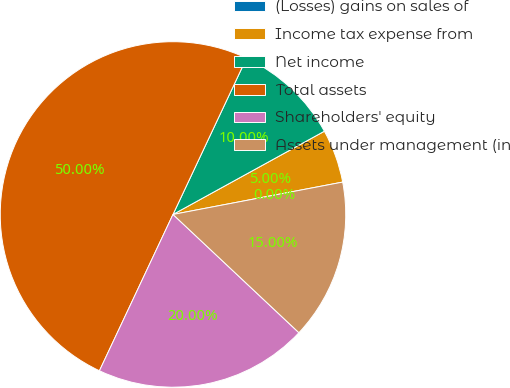<chart> <loc_0><loc_0><loc_500><loc_500><pie_chart><fcel>(Losses) gains on sales of<fcel>Income tax expense from<fcel>Net income<fcel>Total assets<fcel>Shareholders' equity<fcel>Assets under management (in<nl><fcel>0.0%<fcel>5.0%<fcel>10.0%<fcel>50.0%<fcel>20.0%<fcel>15.0%<nl></chart> 